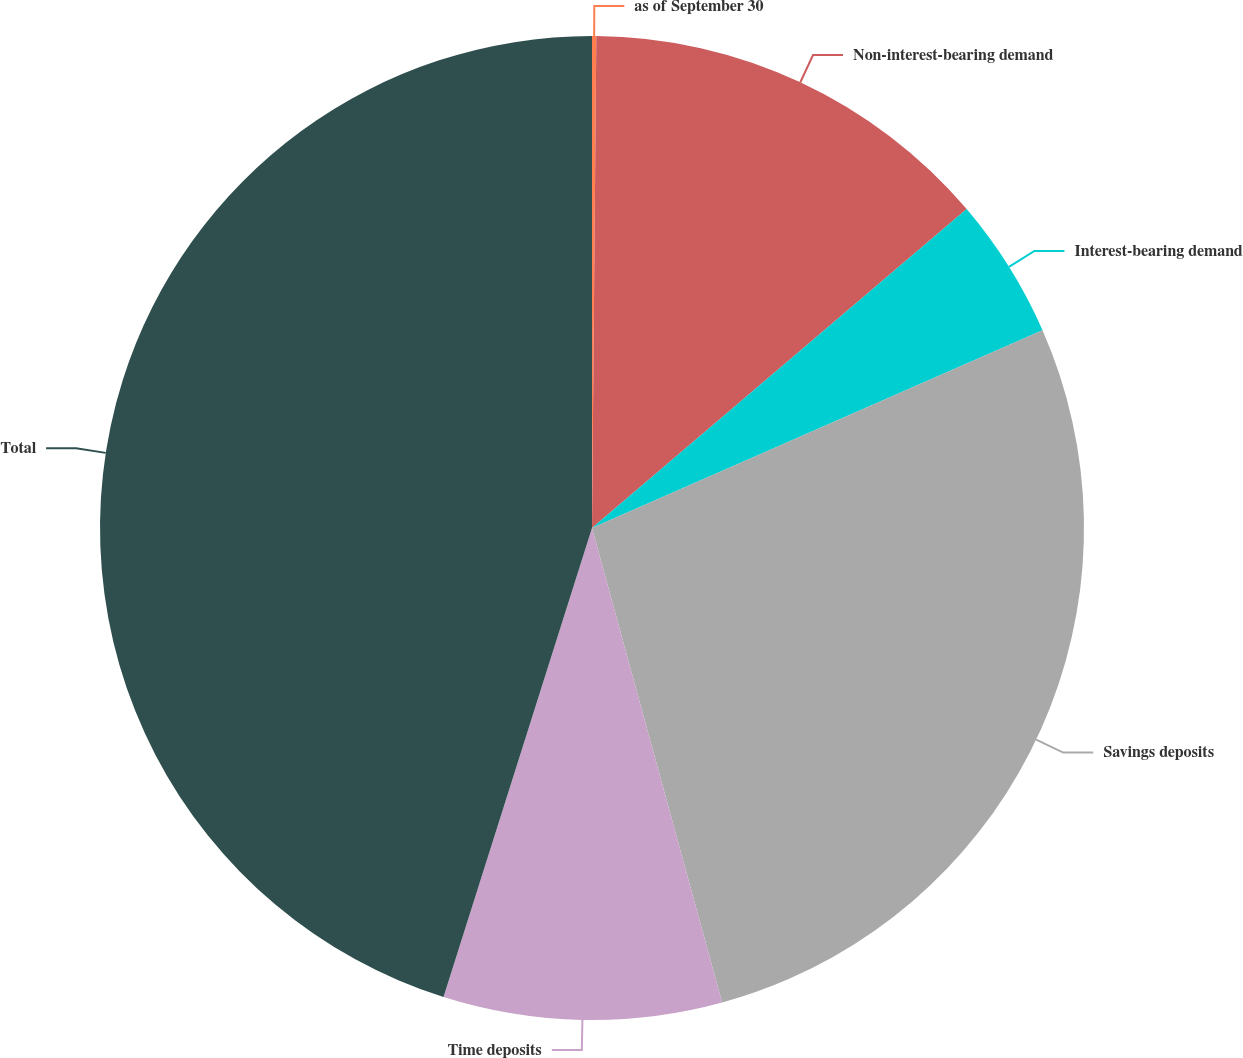Convert chart to OTSL. <chart><loc_0><loc_0><loc_500><loc_500><pie_chart><fcel>as of September 30<fcel>Non-interest-bearing demand<fcel>Interest-bearing demand<fcel>Savings deposits<fcel>Time deposits<fcel>Total<nl><fcel>0.14%<fcel>13.64%<fcel>4.64%<fcel>27.33%<fcel>9.14%<fcel>45.13%<nl></chart> 